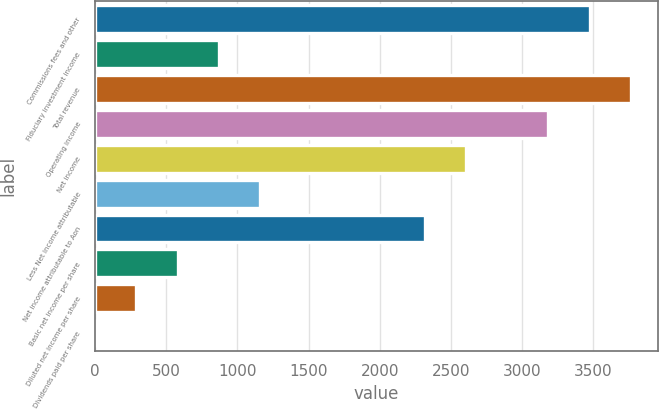Convert chart. <chart><loc_0><loc_0><loc_500><loc_500><bar_chart><fcel>Commissions fees and other<fcel>Fiduciary investment income<fcel>Total revenue<fcel>Operating income<fcel>Net income<fcel>Less Net income attributable<fcel>Net income attributable to Aon<fcel>Basic net income per share<fcel>Diluted net income per share<fcel>Dividends paid per share<nl><fcel>3476.34<fcel>869.22<fcel>3766.02<fcel>3186.66<fcel>2607.3<fcel>1158.9<fcel>2317.62<fcel>579.54<fcel>289.86<fcel>0.18<nl></chart> 